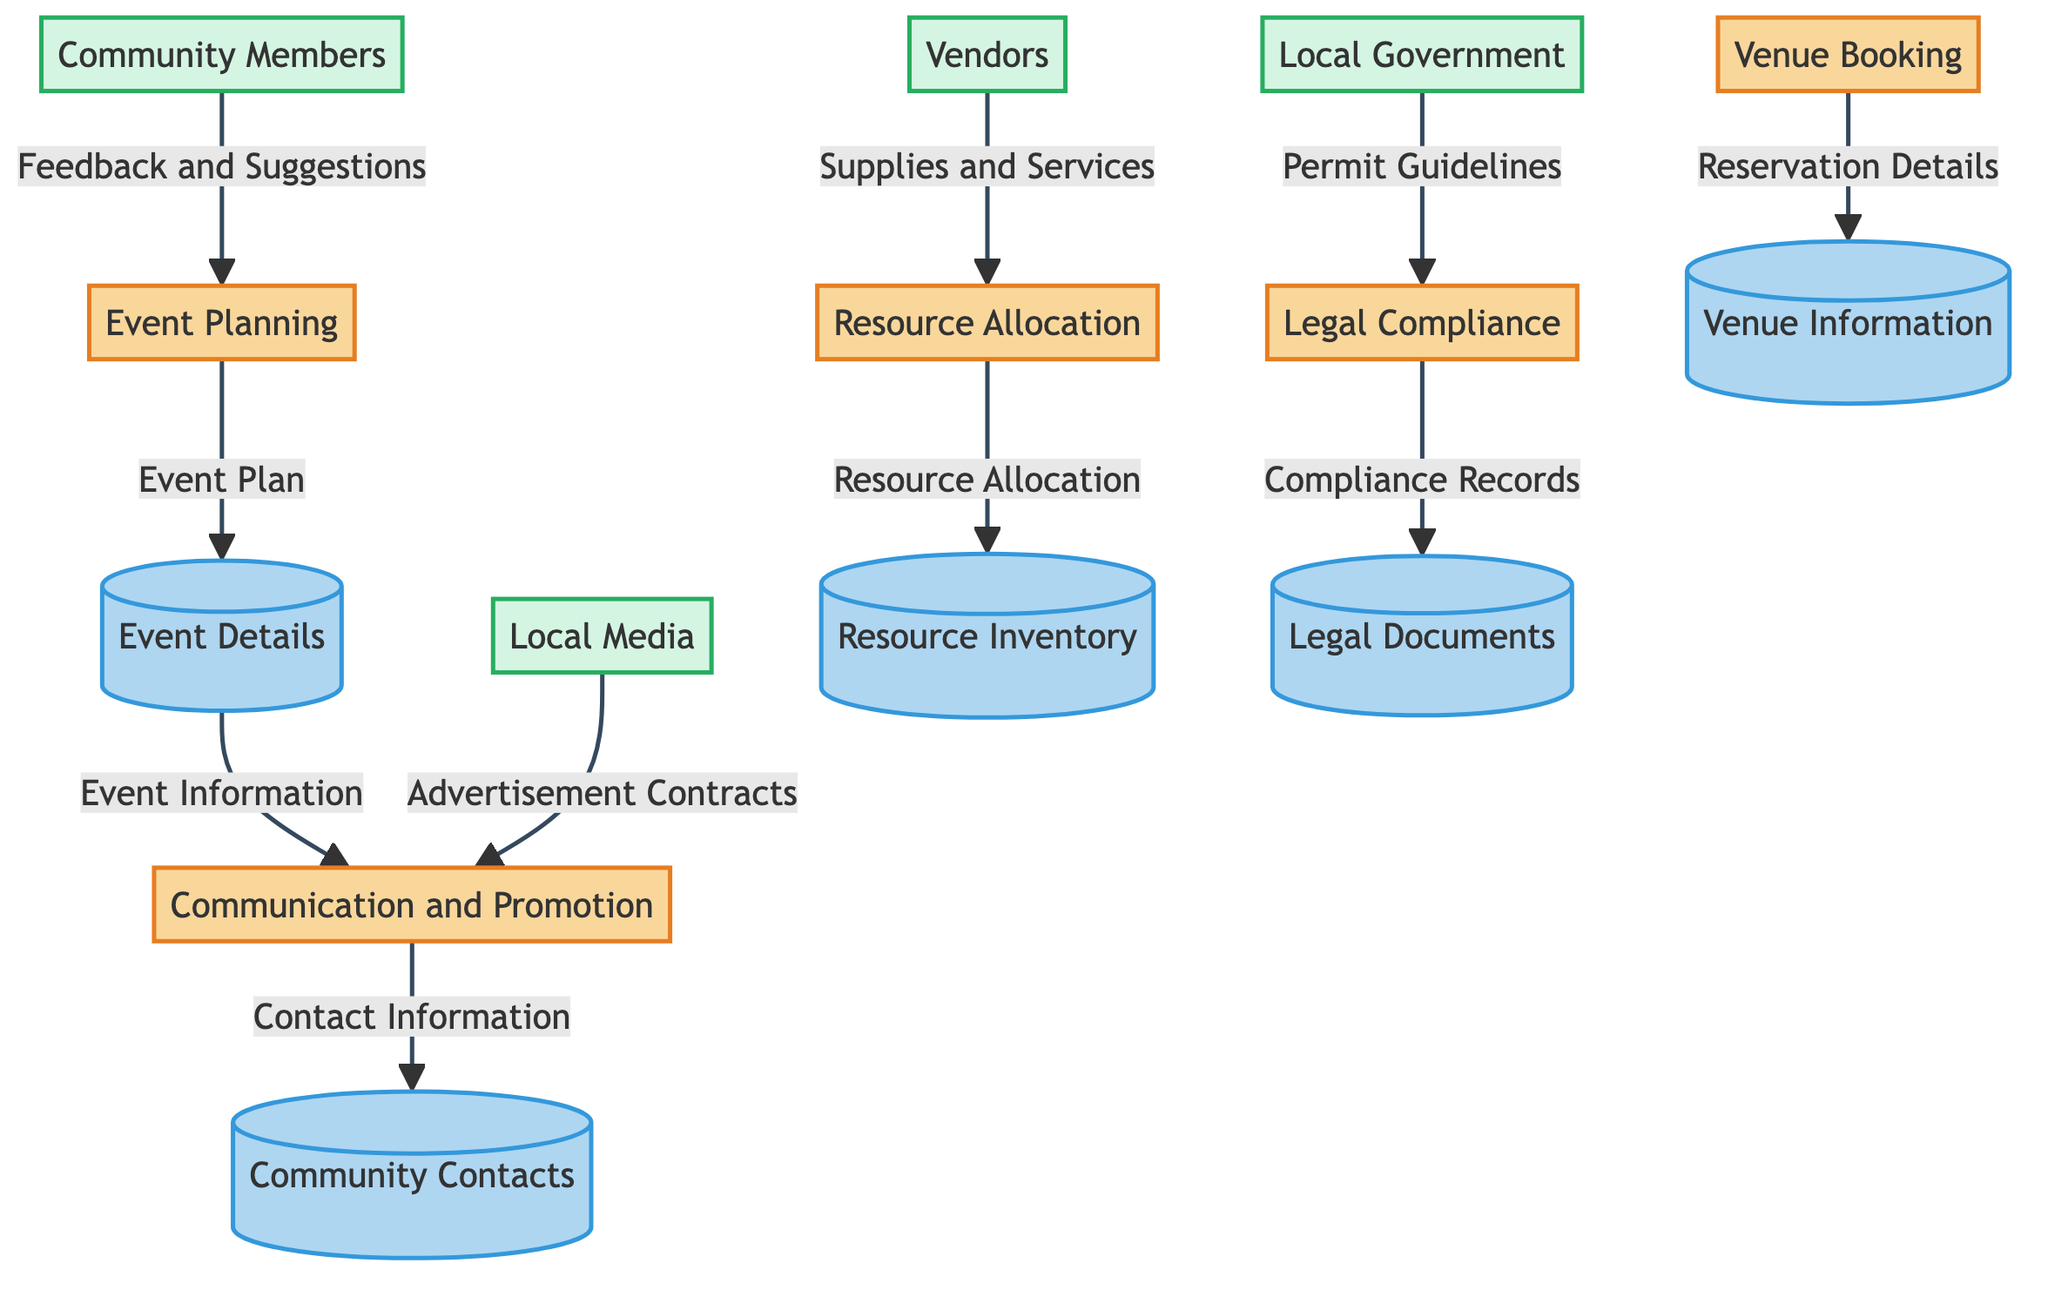What are the processes involved in community event planning? The diagram outlines five processes: Event Planning, Venue Booking, Communication and Promotion, Resource Allocation, and Legal Compliance.
Answer: Five How many data stores are present in the diagram? The diagram includes five data stores: Event Details, Venue Information, Community Contacts, Resource Inventory, and Legal Documents.
Answer: Five What data flow is directed from Local Government to Legal Compliance? The data flow from Local Government to Legal Compliance is labeled as "Permit Guidelines".
Answer: Permit Guidelines Which entity provides supplies and services for the event? The entity that provides supplies and services is labeled as "Vendors".
Answer: Vendors Which process receives feedback and suggestions from Community Members? The process that receives feedback and suggestions is "Event Planning".
Answer: Event Planning What information does the Event Details data store provide to the Communication and Promotion process? The Event Details data store provides "Event Information" to the Communication and Promotion process.
Answer: Event Information How many entities are involved in the diagram? There are four entities involved: Local Government, Community Members, Vendors, and Local Media.
Answer: Four Which process is responsible for ensuring compliance with local regulations? The process responsible for ensuring compliance is "Legal Compliance".
Answer: Legal Compliance What data does the Communication and Promotion process send to the Community Contacts data store? The Communication and Promotion process sends "Contact Information" to the Community Contacts data store.
Answer: Contact Information What is the connection between Venue Booking and Venue Information data store? Venue Booking sends data labeled "Reservation Details" to the Venue Information data store.
Answer: Reservation Details 